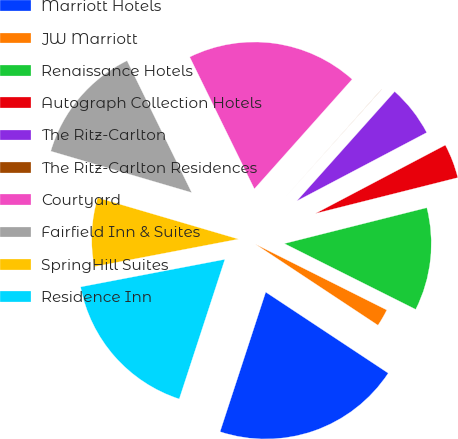Convert chart to OTSL. <chart><loc_0><loc_0><loc_500><loc_500><pie_chart><fcel>Marriott Hotels<fcel>JW Marriott<fcel>Renaissance Hotels<fcel>Autograph Collection Hotels<fcel>The Ritz-Carlton<fcel>The Ritz-Carlton Residences<fcel>Courtyard<fcel>Fairfield Inn & Suites<fcel>SpringHill Suites<fcel>Residence Inn<nl><fcel>20.73%<fcel>1.91%<fcel>11.32%<fcel>3.79%<fcel>5.67%<fcel>0.02%<fcel>18.85%<fcel>13.2%<fcel>7.55%<fcel>16.97%<nl></chart> 